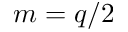Convert formula to latex. <formula><loc_0><loc_0><loc_500><loc_500>m = q / 2</formula> 